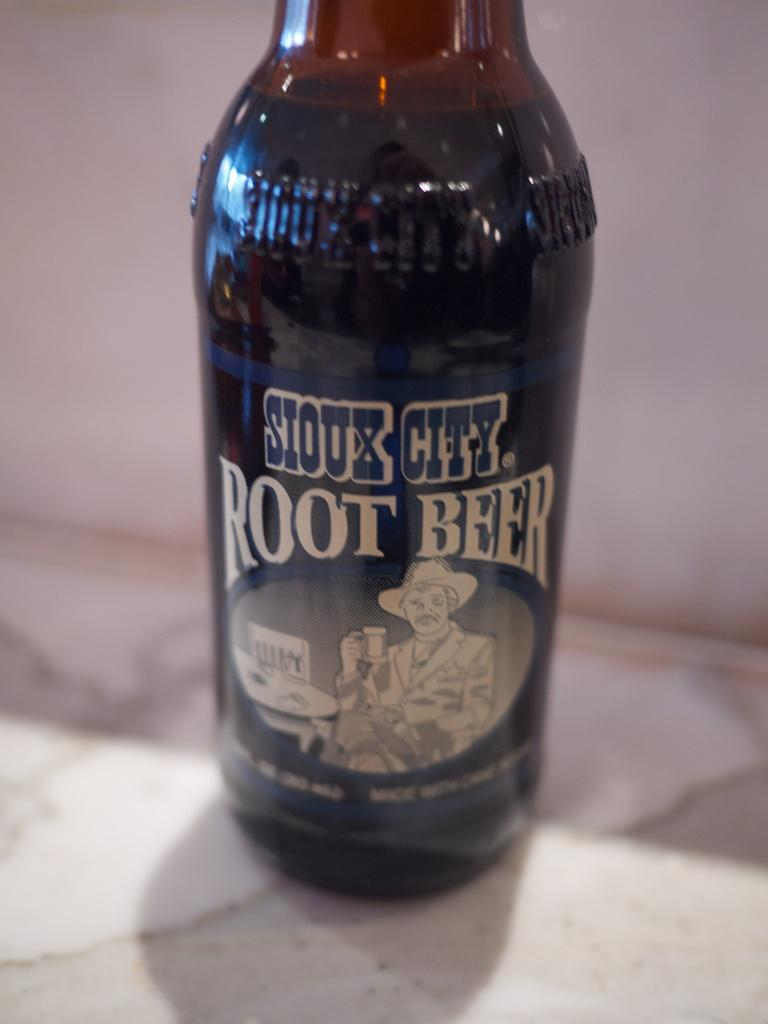Provide a one-sentence caption for the provided image. A bottle of Siox City Root Beer is on the counter. 